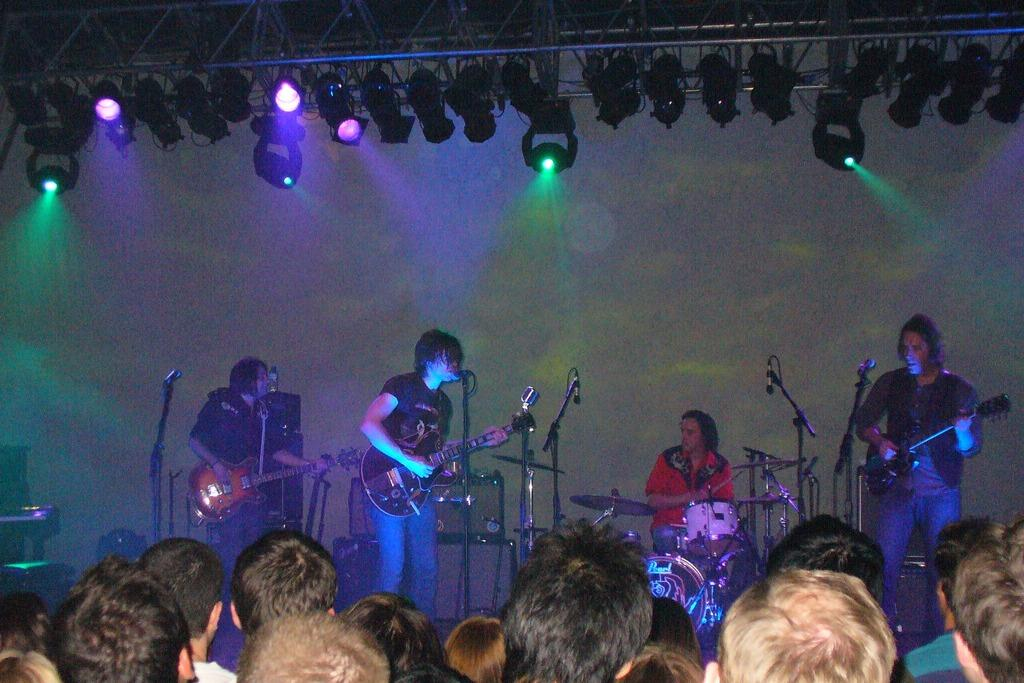What are the three people in the image doing? The three people are playing guitar and singing. What instrument can be heard in the background? One person is playing drums in the background. What is used for amplifying the vocals? There is a microphone present. Who is the performance directed towards? There is an audience in front of the performers. What type of basin is being used to collect the applause from the audience? There is no basin present in the image, and the audience is not applauding into a basin. 